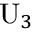<formula> <loc_0><loc_0><loc_500><loc_500>{ U } _ { 3 }</formula> 